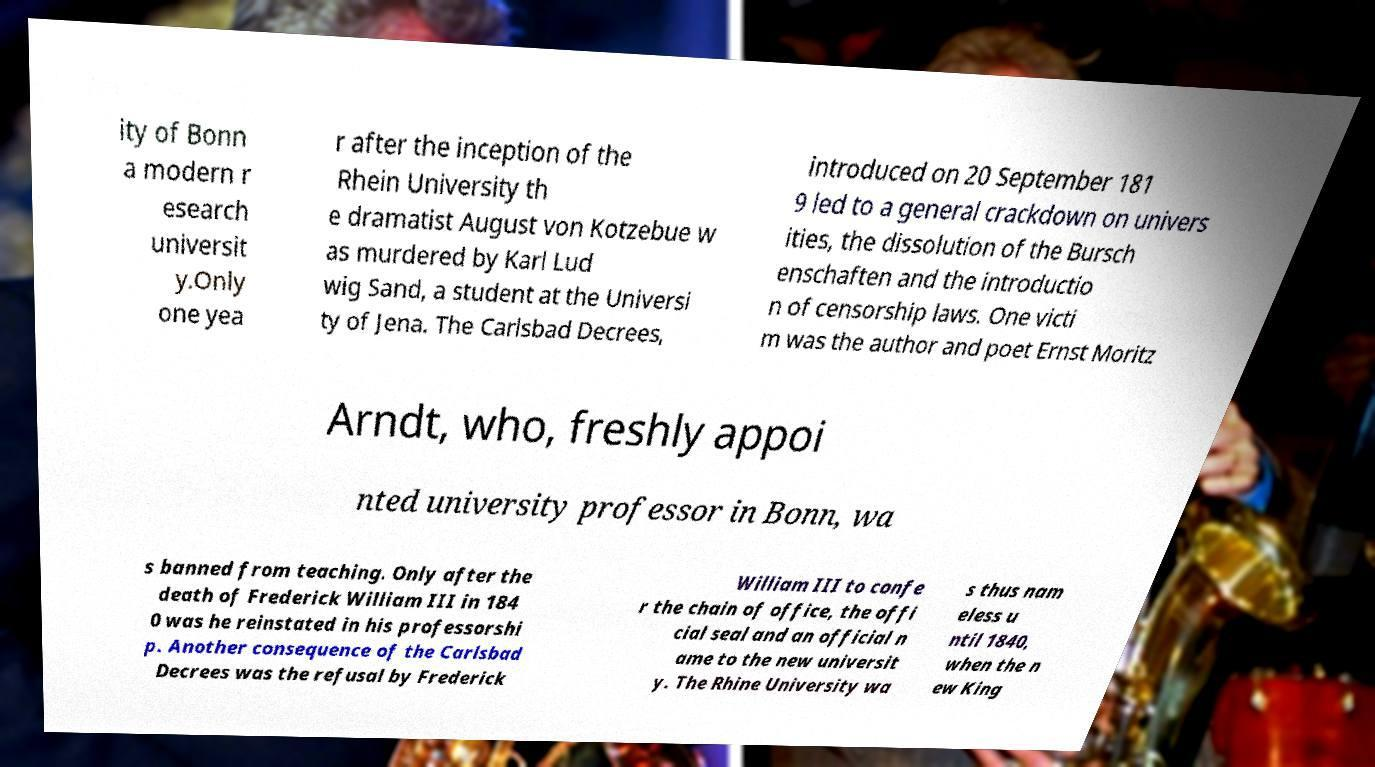Can you read and provide the text displayed in the image?This photo seems to have some interesting text. Can you extract and type it out for me? ity of Bonn a modern r esearch universit y.Only one yea r after the inception of the Rhein University th e dramatist August von Kotzebue w as murdered by Karl Lud wig Sand, a student at the Universi ty of Jena. The Carlsbad Decrees, introduced on 20 September 181 9 led to a general crackdown on univers ities, the dissolution of the Bursch enschaften and the introductio n of censorship laws. One victi m was the author and poet Ernst Moritz Arndt, who, freshly appoi nted university professor in Bonn, wa s banned from teaching. Only after the death of Frederick William III in 184 0 was he reinstated in his professorshi p. Another consequence of the Carlsbad Decrees was the refusal by Frederick William III to confe r the chain of office, the offi cial seal and an official n ame to the new universit y. The Rhine University wa s thus nam eless u ntil 1840, when the n ew King 